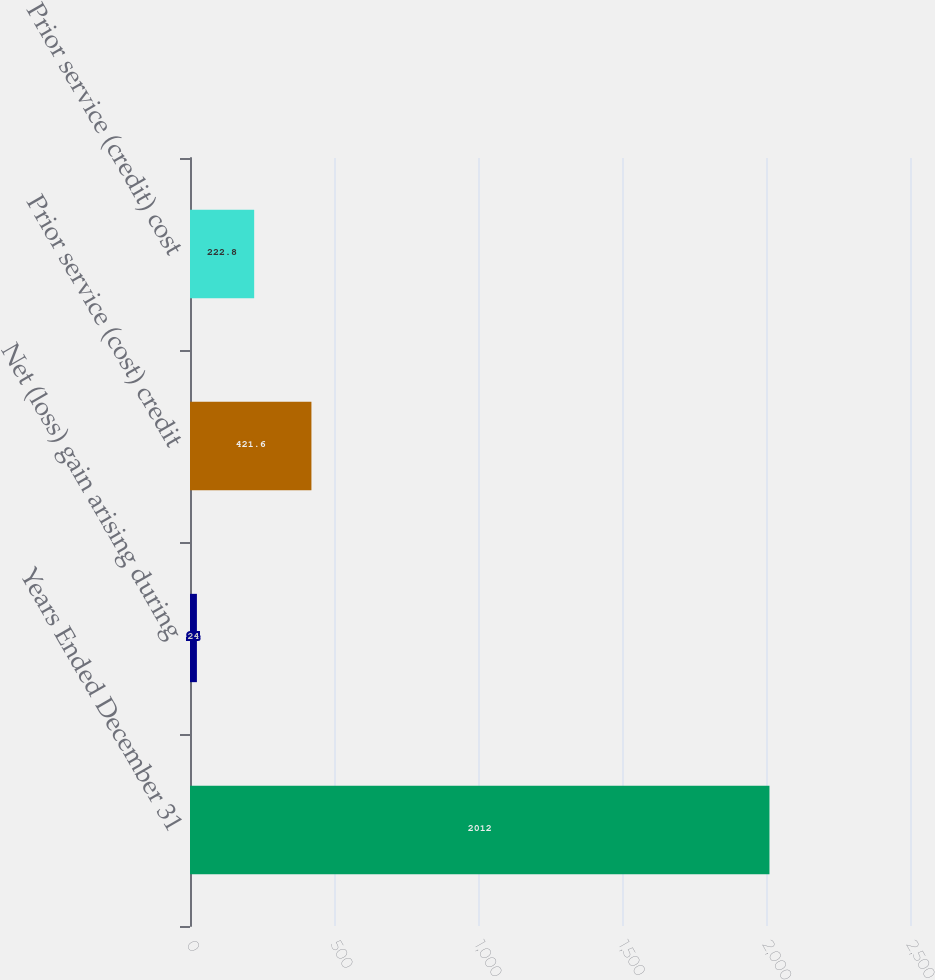Convert chart. <chart><loc_0><loc_0><loc_500><loc_500><bar_chart><fcel>Years Ended December 31<fcel>Net (loss) gain arising during<fcel>Prior service (cost) credit<fcel>Prior service (credit) cost<nl><fcel>2012<fcel>24<fcel>421.6<fcel>222.8<nl></chart> 